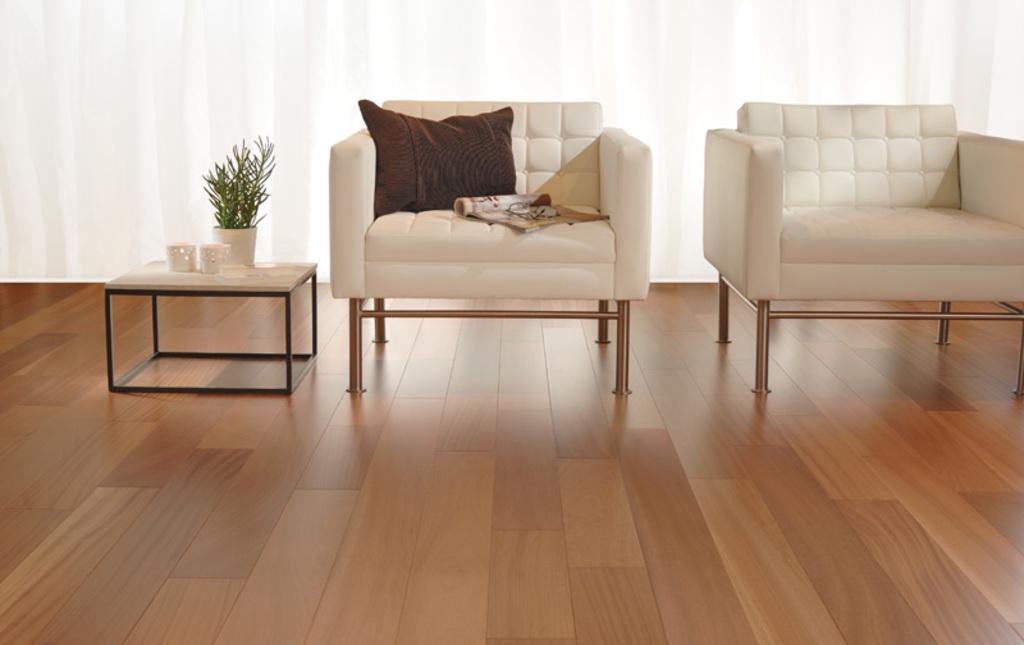How many chairs are visible in the image? There are two chairs in the image. What is placed on one of the chairs? There is a pillow on one of the chairs. What other piece of furniture is present in the image? There is a table in the image. What is on the table? There is a plant in a pot on the table. What type of screw is holding the plant in the pot in the image? There is no screw present in the image; the plant is in a pot on the table. Can you see the grandfather in the image? There is no mention of a grandfather in the image, so it cannot be determined if he is present. 